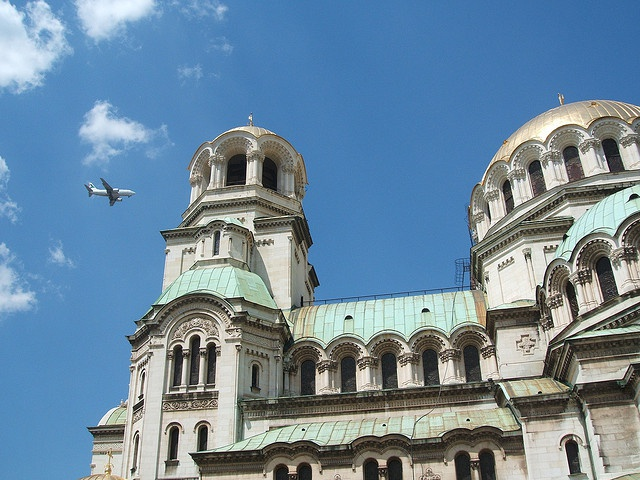Describe the objects in this image and their specific colors. I can see a airplane in lightblue, gray, white, and blue tones in this image. 